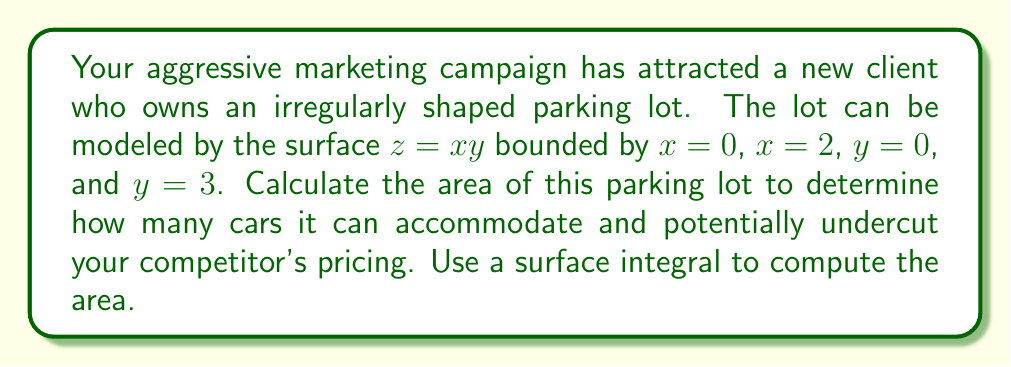Help me with this question. To calculate the area of the irregular-shaped parking lot, we need to use a surface integral. The steps are as follows:

1) The surface area is given by the double integral:

   $$ A = \iint_S \sqrt{1 + (\frac{\partial z}{\partial x})^2 + (\frac{\partial z}{\partial y})^2} \, dA $$

2) We have $z = xy$, so:
   $\frac{\partial z}{\partial x} = y$ and $\frac{\partial z}{\partial y} = x$

3) Substituting into the formula:

   $$ A = \int_0^3 \int_0^2 \sqrt{1 + y^2 + x^2} \, dx \, dy $$

4) This integral is difficult to evaluate directly. We can simplify it using the substitution $u = 1 + x^2 + y^2$:

   $$ A = \frac{1}{2} \int_0^3 \int_0^2 \sqrt{1 + x^2 + y^2} \, d(1+x^2+y^2) \, dy $$

5) Evaluating the inner integral:

   $$ A = \frac{1}{2} \int_0^3 \left[ \frac{2}{3}(1+x^2+y^2)^{3/2} \right]_{x=0}^{x=2} \, dy $$

6) Simplifying:

   $$ A = \frac{1}{3} \int_0^3 \left[(1+4+y^2)^{3/2} - (1+y^2)^{3/2}\right] \, dy $$

7) This integral doesn't have an elementary antiderivative. We need to evaluate it numerically.

8) Using numerical integration, we get:

   $$ A \approx 7.51 \text{ square units} $$
Answer: $7.51 \text{ square units}$ 